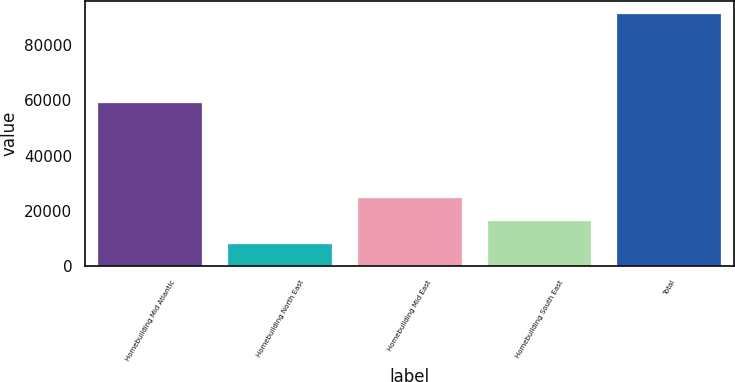Convert chart. <chart><loc_0><loc_0><loc_500><loc_500><bar_chart><fcel>Homebuilding Mid Atlantic<fcel>Homebuilding North East<fcel>Homebuilding Mid East<fcel>Homebuilding South East<fcel>Total<nl><fcel>59144<fcel>8187<fcel>24851<fcel>16519<fcel>91507<nl></chart> 